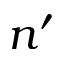<formula> <loc_0><loc_0><loc_500><loc_500>n ^ { \prime }</formula> 